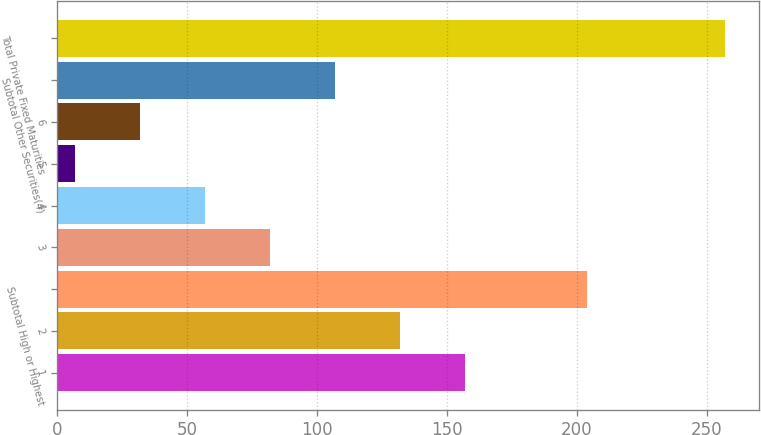Convert chart. <chart><loc_0><loc_0><loc_500><loc_500><bar_chart><fcel>1<fcel>2<fcel>Subtotal High or Highest<fcel>3<fcel>4<fcel>5<fcel>6<fcel>Subtotal Other Securities(4)<fcel>Total Private Fixed Maturities<nl><fcel>157<fcel>132<fcel>204<fcel>82<fcel>57<fcel>7<fcel>32<fcel>107<fcel>257<nl></chart> 